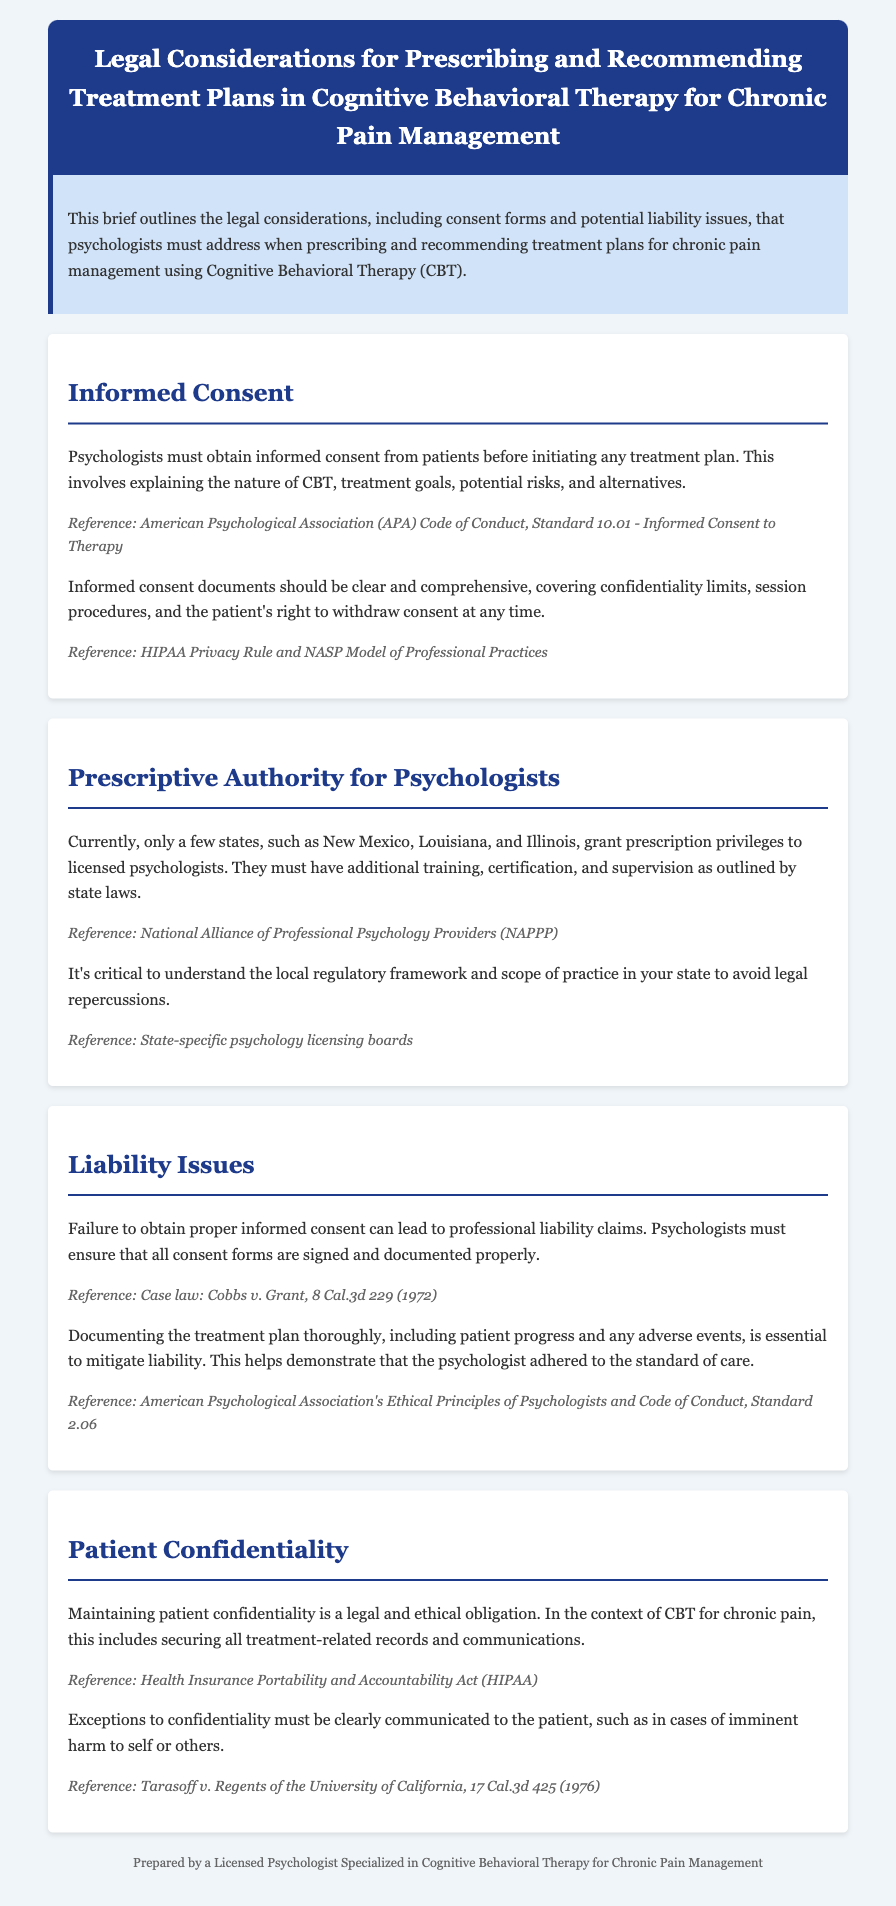what must psychologists obtain from patients before initiating treatment? The document states that psychologists must obtain informed consent from patients before initiating any treatment plan.
Answer: informed consent which states grant prescription privileges to psychologists? The brief mentions that only a few states, including New Mexico, Louisiana, and Illinois, grant prescription privileges to licensed psychologists.
Answer: New Mexico, Louisiana, Illinois what is the potential consequence of failing to obtain proper informed consent? The brief indicates that failure to obtain proper informed consent can lead to professional liability claims.
Answer: professional liability claims what must be documented to mitigate liability issues? The document emphasizes that documenting the treatment plan thoroughly, including patient progress and any adverse events, is essential to mitigate liability.
Answer: treatment plan what is the reference for the APA Code of Conduct regarding informed consent? The reference for the APA Code of Conduct related to informed consent is Standard 10.01 - Informed Consent to Therapy.
Answer: Standard 10.01 what legal act ensures patient confidentiality? The document refers to the Health Insurance Portability and Accountability Act regarding patient confidentiality.
Answer: HIPAA why must exceptions to confidentiality be communicated to the patient? It must be communicated to the patient because exceptions to confidentiality may involve imminent harm to self or others, as stated in the document.
Answer: imminent harm what is required from psychologists in states with prescriptive authority? The document notes that psychologists must have additional training, certification, and supervision as outlined by state laws in states with prescriptive authority.
Answer: additional training, certification, and supervision what should informed consent documents cover? The brief states that informed consent documents should cover confidentiality limits, session procedures, and the patient's right to withdraw consent at any time.
Answer: confidentiality limits, session procedures, patient's right to withdraw consent 